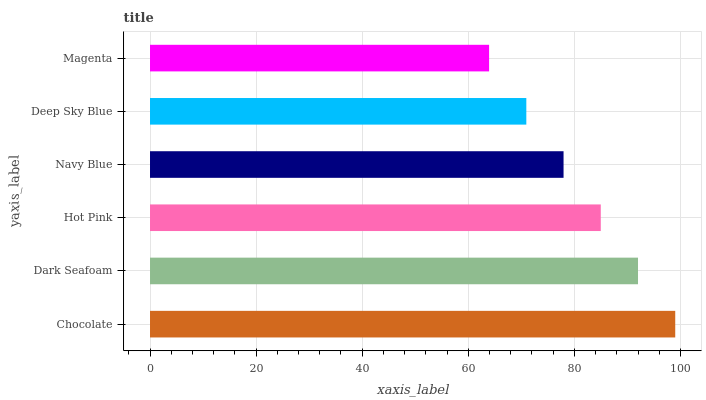Is Magenta the minimum?
Answer yes or no. Yes. Is Chocolate the maximum?
Answer yes or no. Yes. Is Dark Seafoam the minimum?
Answer yes or no. No. Is Dark Seafoam the maximum?
Answer yes or no. No. Is Chocolate greater than Dark Seafoam?
Answer yes or no. Yes. Is Dark Seafoam less than Chocolate?
Answer yes or no. Yes. Is Dark Seafoam greater than Chocolate?
Answer yes or no. No. Is Chocolate less than Dark Seafoam?
Answer yes or no. No. Is Hot Pink the high median?
Answer yes or no. Yes. Is Navy Blue the low median?
Answer yes or no. Yes. Is Chocolate the high median?
Answer yes or no. No. Is Chocolate the low median?
Answer yes or no. No. 